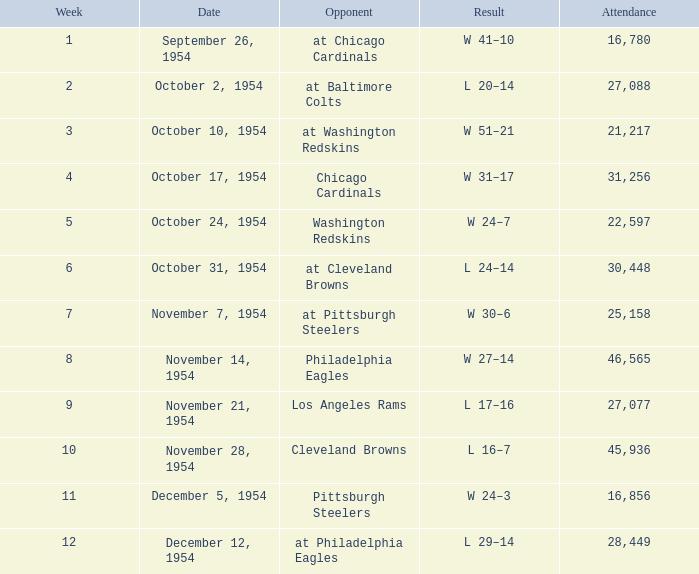How many weeks include october 31, 1954 as the date? 1.0. Would you mind parsing the complete table? {'header': ['Week', 'Date', 'Opponent', 'Result', 'Attendance'], 'rows': [['1', 'September 26, 1954', 'at Chicago Cardinals', 'W 41–10', '16,780'], ['2', 'October 2, 1954', 'at Baltimore Colts', 'L 20–14', '27,088'], ['3', 'October 10, 1954', 'at Washington Redskins', 'W 51–21', '21,217'], ['4', 'October 17, 1954', 'Chicago Cardinals', 'W 31–17', '31,256'], ['5', 'October 24, 1954', 'Washington Redskins', 'W 24–7', '22,597'], ['6', 'October 31, 1954', 'at Cleveland Browns', 'L 24–14', '30,448'], ['7', 'November 7, 1954', 'at Pittsburgh Steelers', 'W 30–6', '25,158'], ['8', 'November 14, 1954', 'Philadelphia Eagles', 'W 27–14', '46,565'], ['9', 'November 21, 1954', 'Los Angeles Rams', 'L 17–16', '27,077'], ['10', 'November 28, 1954', 'Cleveland Browns', 'L 16–7', '45,936'], ['11', 'December 5, 1954', 'Pittsburgh Steelers', 'W 24–3', '16,856'], ['12', 'December 12, 1954', 'at Philadelphia Eagles', 'L 29–14', '28,449']]} 